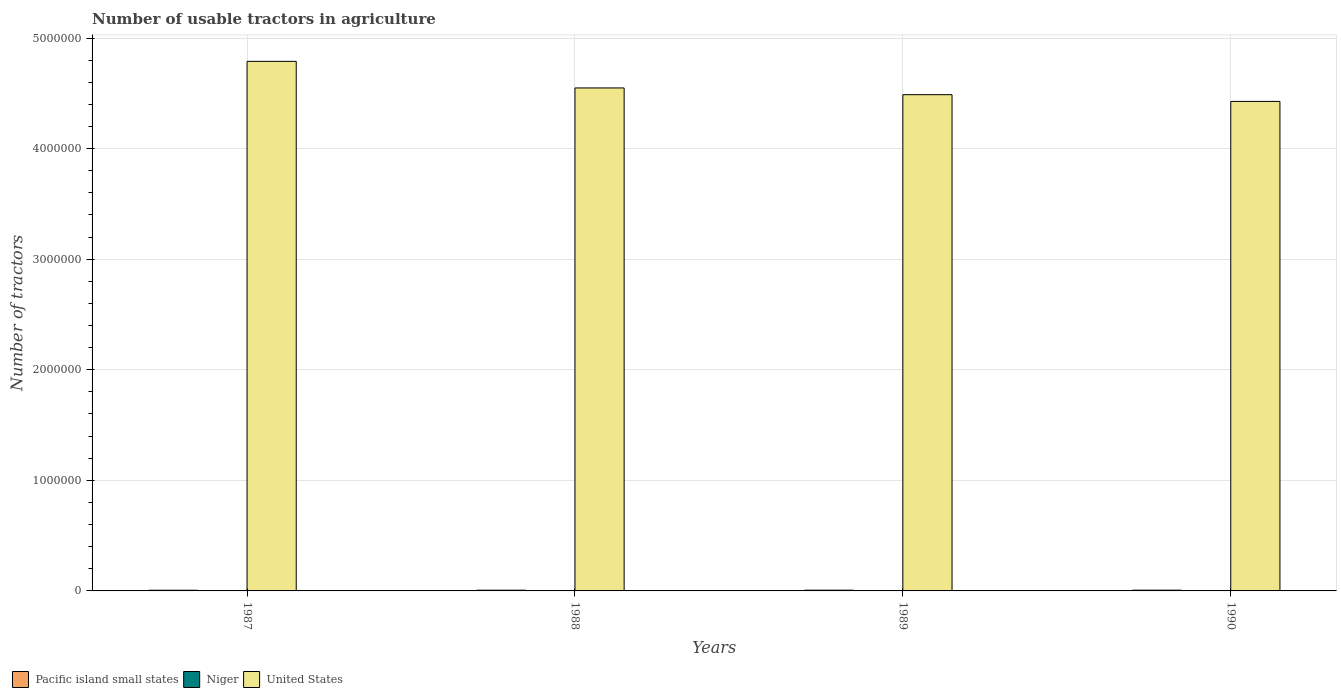How many groups of bars are there?
Ensure brevity in your answer.  4. Are the number of bars per tick equal to the number of legend labels?
Ensure brevity in your answer.  Yes. Are the number of bars on each tick of the X-axis equal?
Offer a terse response. Yes. How many bars are there on the 1st tick from the right?
Your answer should be compact. 3. What is the number of usable tractors in agriculture in Pacific island small states in 1989?
Ensure brevity in your answer.  6710. Across all years, what is the maximum number of usable tractors in agriculture in United States?
Make the answer very short. 4.79e+06. Across all years, what is the minimum number of usable tractors in agriculture in Pacific island small states?
Make the answer very short. 6188. In which year was the number of usable tractors in agriculture in Pacific island small states maximum?
Your answer should be compact. 1990. In which year was the number of usable tractors in agriculture in United States minimum?
Your answer should be very brief. 1990. What is the total number of usable tractors in agriculture in Pacific island small states in the graph?
Make the answer very short. 2.64e+04. What is the difference between the number of usable tractors in agriculture in United States in 1988 and that in 1990?
Ensure brevity in your answer.  1.22e+05. What is the difference between the number of usable tractors in agriculture in Niger in 1988 and the number of usable tractors in agriculture in United States in 1987?
Your response must be concise. -4.79e+06. What is the average number of usable tractors in agriculture in Niger per year?
Your answer should be very brief. 166. In the year 1989, what is the difference between the number of usable tractors in agriculture in Pacific island small states and number of usable tractors in agriculture in United States?
Make the answer very short. -4.48e+06. In how many years, is the number of usable tractors in agriculture in United States greater than 2000000?
Your answer should be compact. 4. What is the ratio of the number of usable tractors in agriculture in Niger in 1987 to that in 1988?
Ensure brevity in your answer.  0.98. Is the difference between the number of usable tractors in agriculture in Pacific island small states in 1987 and 1989 greater than the difference between the number of usable tractors in agriculture in United States in 1987 and 1989?
Provide a short and direct response. No. What is the difference between the highest and the second highest number of usable tractors in agriculture in United States?
Make the answer very short. 2.41e+05. In how many years, is the number of usable tractors in agriculture in Niger greater than the average number of usable tractors in agriculture in Niger taken over all years?
Ensure brevity in your answer.  2. What does the 2nd bar from the left in 1987 represents?
Make the answer very short. Niger. What does the 3rd bar from the right in 1988 represents?
Offer a terse response. Pacific island small states. Does the graph contain grids?
Ensure brevity in your answer.  Yes. How many legend labels are there?
Your response must be concise. 3. What is the title of the graph?
Provide a short and direct response. Number of usable tractors in agriculture. What is the label or title of the X-axis?
Provide a short and direct response. Years. What is the label or title of the Y-axis?
Keep it short and to the point. Number of tractors. What is the Number of tractors in Pacific island small states in 1987?
Your answer should be very brief. 6188. What is the Number of tractors of Niger in 1987?
Provide a succinct answer. 158. What is the Number of tractors in United States in 1987?
Ensure brevity in your answer.  4.79e+06. What is the Number of tractors in Pacific island small states in 1988?
Your response must be concise. 6548. What is the Number of tractors in Niger in 1988?
Ensure brevity in your answer.  162. What is the Number of tractors in United States in 1988?
Offer a terse response. 4.55e+06. What is the Number of tractors of Pacific island small states in 1989?
Give a very brief answer. 6710. What is the Number of tractors of Niger in 1989?
Make the answer very short. 174. What is the Number of tractors in United States in 1989?
Your answer should be compact. 4.49e+06. What is the Number of tractors in Pacific island small states in 1990?
Offer a very short reply. 6915. What is the Number of tractors in Niger in 1990?
Your answer should be compact. 170. What is the Number of tractors of United States in 1990?
Provide a succinct answer. 4.43e+06. Across all years, what is the maximum Number of tractors of Pacific island small states?
Your answer should be compact. 6915. Across all years, what is the maximum Number of tractors in Niger?
Make the answer very short. 174. Across all years, what is the maximum Number of tractors of United States?
Make the answer very short. 4.79e+06. Across all years, what is the minimum Number of tractors in Pacific island small states?
Your answer should be compact. 6188. Across all years, what is the minimum Number of tractors in Niger?
Provide a succinct answer. 158. Across all years, what is the minimum Number of tractors in United States?
Keep it short and to the point. 4.43e+06. What is the total Number of tractors of Pacific island small states in the graph?
Provide a short and direct response. 2.64e+04. What is the total Number of tractors of Niger in the graph?
Provide a short and direct response. 664. What is the total Number of tractors in United States in the graph?
Offer a very short reply. 1.83e+07. What is the difference between the Number of tractors of Pacific island small states in 1987 and that in 1988?
Provide a short and direct response. -360. What is the difference between the Number of tractors in United States in 1987 and that in 1988?
Keep it short and to the point. 2.41e+05. What is the difference between the Number of tractors of Pacific island small states in 1987 and that in 1989?
Your answer should be compact. -522. What is the difference between the Number of tractors of Niger in 1987 and that in 1989?
Your answer should be very brief. -16. What is the difference between the Number of tractors of United States in 1987 and that in 1989?
Give a very brief answer. 3.01e+05. What is the difference between the Number of tractors in Pacific island small states in 1987 and that in 1990?
Your response must be concise. -727. What is the difference between the Number of tractors in United States in 1987 and that in 1990?
Provide a succinct answer. 3.62e+05. What is the difference between the Number of tractors in Pacific island small states in 1988 and that in 1989?
Provide a succinct answer. -162. What is the difference between the Number of tractors in United States in 1988 and that in 1989?
Provide a succinct answer. 6.09e+04. What is the difference between the Number of tractors in Pacific island small states in 1988 and that in 1990?
Make the answer very short. -367. What is the difference between the Number of tractors of United States in 1988 and that in 1990?
Provide a succinct answer. 1.22e+05. What is the difference between the Number of tractors in Pacific island small states in 1989 and that in 1990?
Ensure brevity in your answer.  -205. What is the difference between the Number of tractors of Niger in 1989 and that in 1990?
Your response must be concise. 4. What is the difference between the Number of tractors of United States in 1989 and that in 1990?
Keep it short and to the point. 6.09e+04. What is the difference between the Number of tractors in Pacific island small states in 1987 and the Number of tractors in Niger in 1988?
Provide a succinct answer. 6026. What is the difference between the Number of tractors of Pacific island small states in 1987 and the Number of tractors of United States in 1988?
Make the answer very short. -4.54e+06. What is the difference between the Number of tractors in Niger in 1987 and the Number of tractors in United States in 1988?
Your answer should be compact. -4.55e+06. What is the difference between the Number of tractors in Pacific island small states in 1987 and the Number of tractors in Niger in 1989?
Provide a short and direct response. 6014. What is the difference between the Number of tractors of Pacific island small states in 1987 and the Number of tractors of United States in 1989?
Your answer should be compact. -4.48e+06. What is the difference between the Number of tractors of Niger in 1987 and the Number of tractors of United States in 1989?
Provide a succinct answer. -4.49e+06. What is the difference between the Number of tractors in Pacific island small states in 1987 and the Number of tractors in Niger in 1990?
Give a very brief answer. 6018. What is the difference between the Number of tractors of Pacific island small states in 1987 and the Number of tractors of United States in 1990?
Make the answer very short. -4.42e+06. What is the difference between the Number of tractors of Niger in 1987 and the Number of tractors of United States in 1990?
Provide a succinct answer. -4.43e+06. What is the difference between the Number of tractors of Pacific island small states in 1988 and the Number of tractors of Niger in 1989?
Offer a very short reply. 6374. What is the difference between the Number of tractors of Pacific island small states in 1988 and the Number of tractors of United States in 1989?
Give a very brief answer. -4.48e+06. What is the difference between the Number of tractors of Niger in 1988 and the Number of tractors of United States in 1989?
Your answer should be very brief. -4.49e+06. What is the difference between the Number of tractors of Pacific island small states in 1988 and the Number of tractors of Niger in 1990?
Provide a succinct answer. 6378. What is the difference between the Number of tractors of Pacific island small states in 1988 and the Number of tractors of United States in 1990?
Your response must be concise. -4.42e+06. What is the difference between the Number of tractors in Niger in 1988 and the Number of tractors in United States in 1990?
Your answer should be very brief. -4.43e+06. What is the difference between the Number of tractors in Pacific island small states in 1989 and the Number of tractors in Niger in 1990?
Provide a succinct answer. 6540. What is the difference between the Number of tractors in Pacific island small states in 1989 and the Number of tractors in United States in 1990?
Offer a very short reply. -4.42e+06. What is the difference between the Number of tractors in Niger in 1989 and the Number of tractors in United States in 1990?
Provide a succinct answer. -4.43e+06. What is the average Number of tractors in Pacific island small states per year?
Offer a very short reply. 6590.25. What is the average Number of tractors in Niger per year?
Your answer should be very brief. 166. What is the average Number of tractors of United States per year?
Give a very brief answer. 4.56e+06. In the year 1987, what is the difference between the Number of tractors of Pacific island small states and Number of tractors of Niger?
Give a very brief answer. 6030. In the year 1987, what is the difference between the Number of tractors in Pacific island small states and Number of tractors in United States?
Make the answer very short. -4.78e+06. In the year 1987, what is the difference between the Number of tractors in Niger and Number of tractors in United States?
Your answer should be very brief. -4.79e+06. In the year 1988, what is the difference between the Number of tractors in Pacific island small states and Number of tractors in Niger?
Your answer should be compact. 6386. In the year 1988, what is the difference between the Number of tractors of Pacific island small states and Number of tractors of United States?
Make the answer very short. -4.54e+06. In the year 1988, what is the difference between the Number of tractors in Niger and Number of tractors in United States?
Provide a short and direct response. -4.55e+06. In the year 1989, what is the difference between the Number of tractors in Pacific island small states and Number of tractors in Niger?
Ensure brevity in your answer.  6536. In the year 1989, what is the difference between the Number of tractors of Pacific island small states and Number of tractors of United States?
Ensure brevity in your answer.  -4.48e+06. In the year 1989, what is the difference between the Number of tractors in Niger and Number of tractors in United States?
Offer a terse response. -4.49e+06. In the year 1990, what is the difference between the Number of tractors of Pacific island small states and Number of tractors of Niger?
Your response must be concise. 6745. In the year 1990, what is the difference between the Number of tractors of Pacific island small states and Number of tractors of United States?
Offer a very short reply. -4.42e+06. In the year 1990, what is the difference between the Number of tractors of Niger and Number of tractors of United States?
Your answer should be compact. -4.43e+06. What is the ratio of the Number of tractors of Pacific island small states in 1987 to that in 1988?
Your answer should be compact. 0.94. What is the ratio of the Number of tractors of Niger in 1987 to that in 1988?
Ensure brevity in your answer.  0.98. What is the ratio of the Number of tractors in United States in 1987 to that in 1988?
Offer a terse response. 1.05. What is the ratio of the Number of tractors of Pacific island small states in 1987 to that in 1989?
Keep it short and to the point. 0.92. What is the ratio of the Number of tractors in Niger in 1987 to that in 1989?
Ensure brevity in your answer.  0.91. What is the ratio of the Number of tractors in United States in 1987 to that in 1989?
Your answer should be very brief. 1.07. What is the ratio of the Number of tractors in Pacific island small states in 1987 to that in 1990?
Ensure brevity in your answer.  0.89. What is the ratio of the Number of tractors of Niger in 1987 to that in 1990?
Keep it short and to the point. 0.93. What is the ratio of the Number of tractors of United States in 1987 to that in 1990?
Your answer should be very brief. 1.08. What is the ratio of the Number of tractors of Pacific island small states in 1988 to that in 1989?
Your response must be concise. 0.98. What is the ratio of the Number of tractors of Niger in 1988 to that in 1989?
Your answer should be very brief. 0.93. What is the ratio of the Number of tractors of United States in 1988 to that in 1989?
Keep it short and to the point. 1.01. What is the ratio of the Number of tractors of Pacific island small states in 1988 to that in 1990?
Ensure brevity in your answer.  0.95. What is the ratio of the Number of tractors of Niger in 1988 to that in 1990?
Offer a very short reply. 0.95. What is the ratio of the Number of tractors of United States in 1988 to that in 1990?
Provide a succinct answer. 1.03. What is the ratio of the Number of tractors in Pacific island small states in 1989 to that in 1990?
Keep it short and to the point. 0.97. What is the ratio of the Number of tractors in Niger in 1989 to that in 1990?
Make the answer very short. 1.02. What is the ratio of the Number of tractors in United States in 1989 to that in 1990?
Your answer should be very brief. 1.01. What is the difference between the highest and the second highest Number of tractors of Pacific island small states?
Ensure brevity in your answer.  205. What is the difference between the highest and the second highest Number of tractors of United States?
Offer a terse response. 2.41e+05. What is the difference between the highest and the lowest Number of tractors of Pacific island small states?
Your answer should be very brief. 727. What is the difference between the highest and the lowest Number of tractors in Niger?
Your answer should be compact. 16. What is the difference between the highest and the lowest Number of tractors in United States?
Your response must be concise. 3.62e+05. 